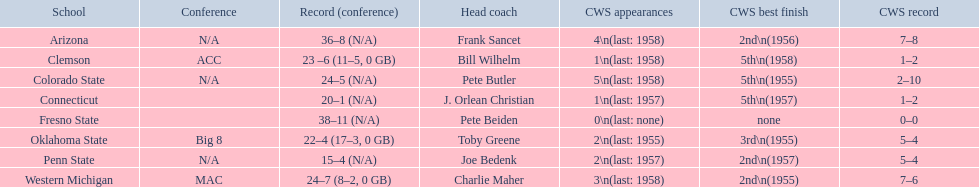Which teams played in the 1959 ncaa university division baseball tournament? Arizona, Clemson, Colorado State, Connecticut, Fresno State, Oklahoma State, Penn State, Western Michigan. Which was the only one to win less than 20 games? Penn State. 